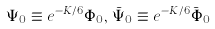<formula> <loc_0><loc_0><loc_500><loc_500>\Psi _ { 0 } \equiv e ^ { - K / 6 } \Phi _ { 0 } , \, \bar { \Psi } _ { 0 } \equiv e ^ { - K / 6 } \bar { \Phi } _ { 0 }</formula> 